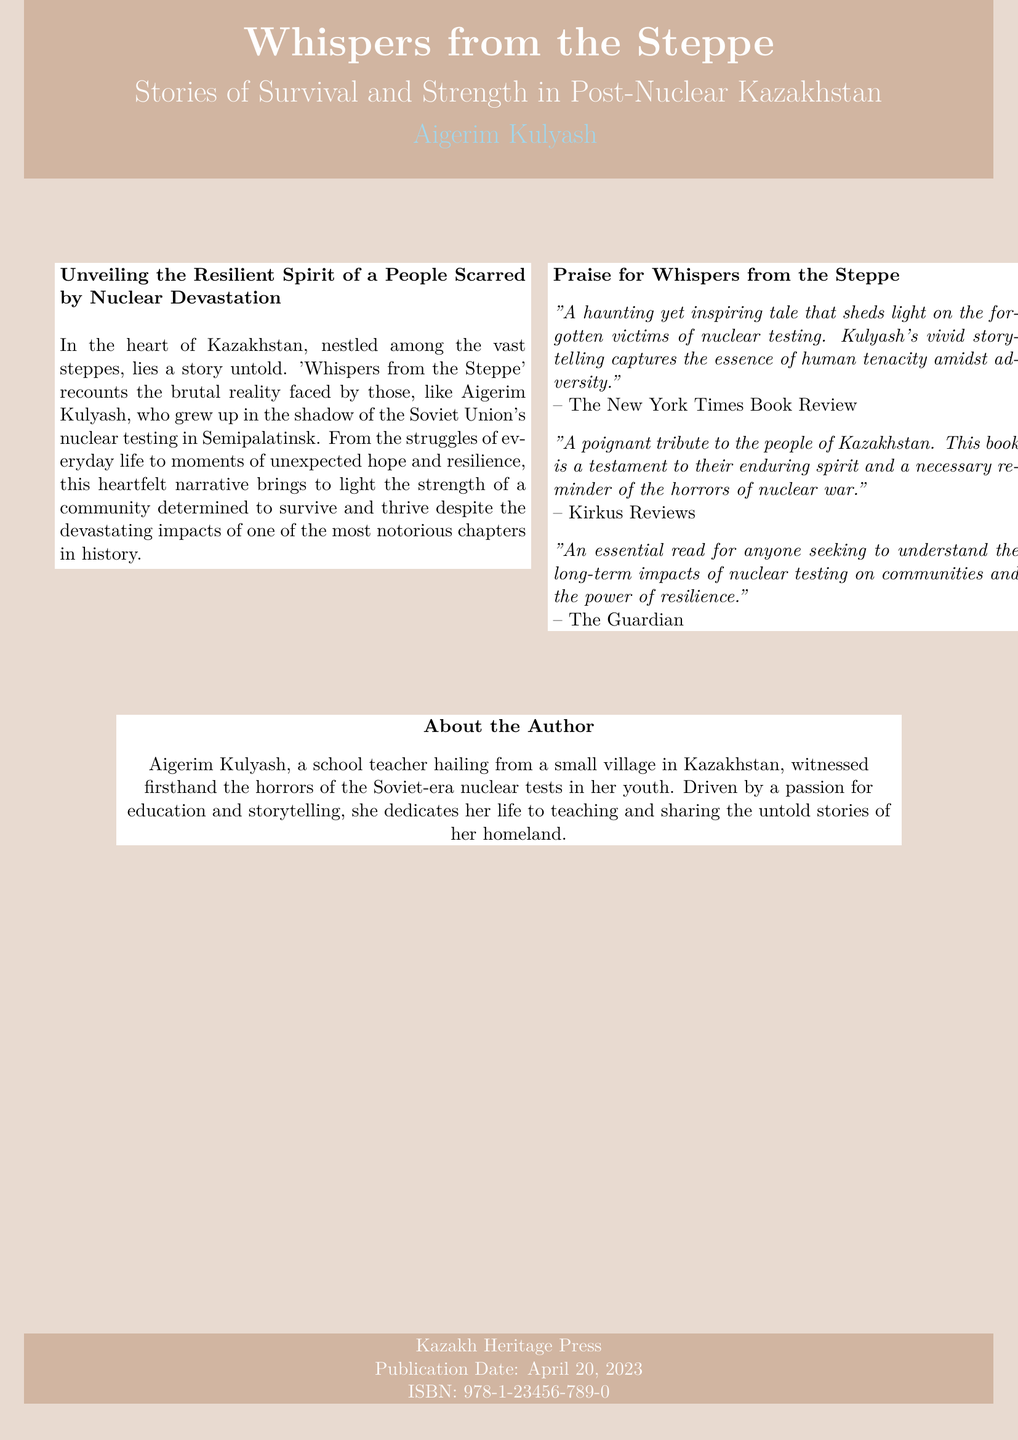What is the title of the book? The title of the book is prominently displayed in large font on the cover, which is "Whispers from the Steppe."
Answer: Whispers from the Steppe Who is the author? The author's name is provided directly below the book title, which is Aigerim Kulyash.
Answer: Aigerim Kulyash What is the publication date? The publication date is mentioned in the footer area of the cover, which shows April 20, 2023.
Answer: April 20, 2023 What color is used for the book cover background? The background color of the cover is described as steppe, which is a shade of brownish color.
Answer: Steppe What aspect of history does the book address? The document indicates that the book recounts the reality faced by those affected by nuclear testing, highlighting its historical context.
Answer: Nuclear testing What type of narrative does the author employ? The narrative style is described as heartfelt, emphasizing emotional connections and storytelling.
Answer: Heartfelt What is the publisher's name? The name of the publisher is shown at the bottom of the cover as Kazakh Heritage Press.
Answer: Kazakh Heritage Press What theme is central to the book? The book centers around survival and resilience in the context of the author’s experiences with nuclear devastation.
Answer: Survival and resilience Which major publication praised the book? The New York Times Book Review is one of the publications that provided praise for the book.
Answer: The New York Times Book Review 